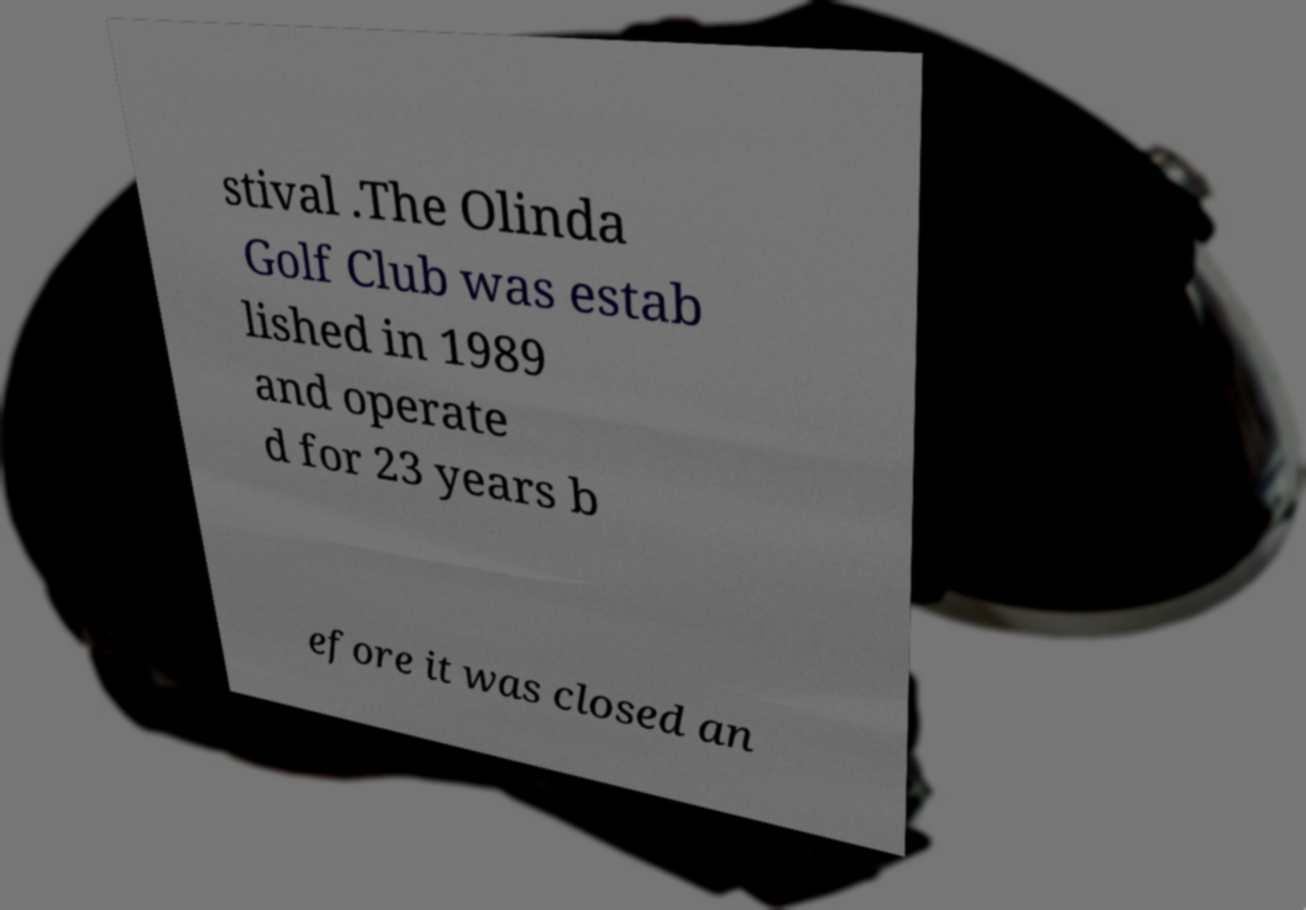There's text embedded in this image that I need extracted. Can you transcribe it verbatim? stival .The Olinda Golf Club was estab lished in 1989 and operate d for 23 years b efore it was closed an 